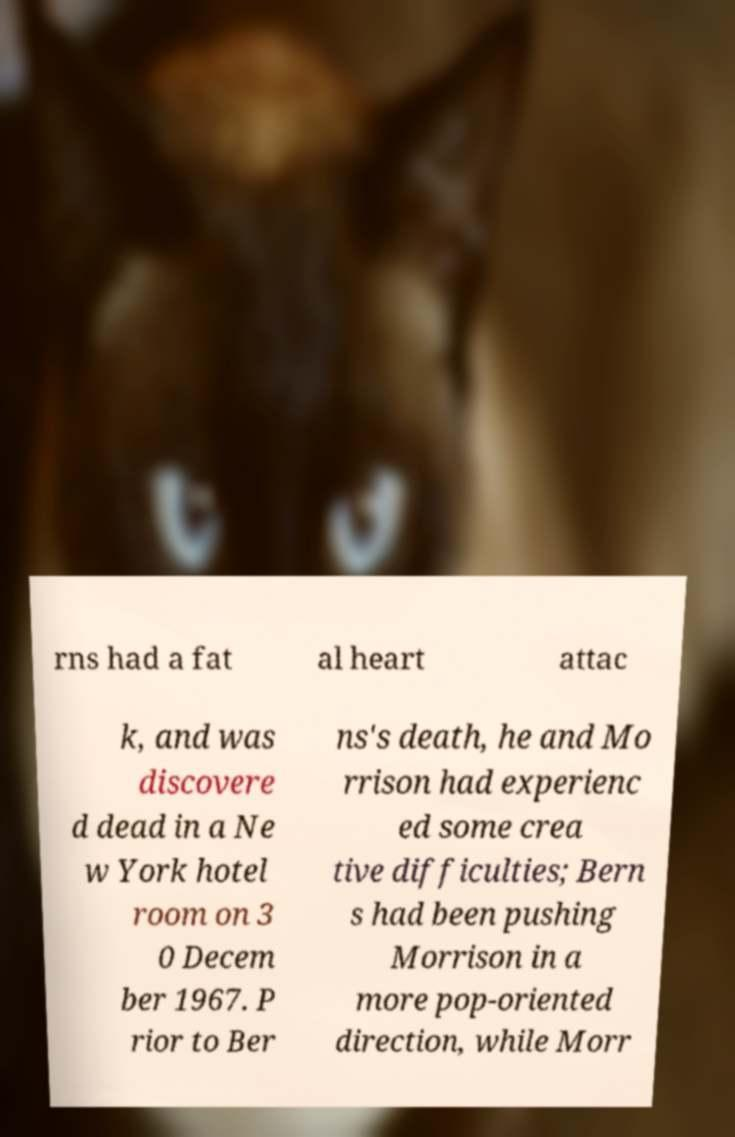For documentation purposes, I need the text within this image transcribed. Could you provide that? rns had a fat al heart attac k, and was discovere d dead in a Ne w York hotel room on 3 0 Decem ber 1967. P rior to Ber ns's death, he and Mo rrison had experienc ed some crea tive difficulties; Bern s had been pushing Morrison in a more pop-oriented direction, while Morr 